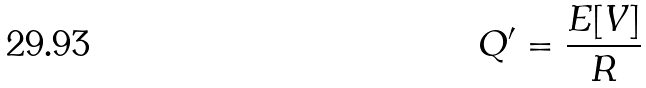<formula> <loc_0><loc_0><loc_500><loc_500>Q ^ { \prime } = \frac { E [ V ] } { R }</formula> 